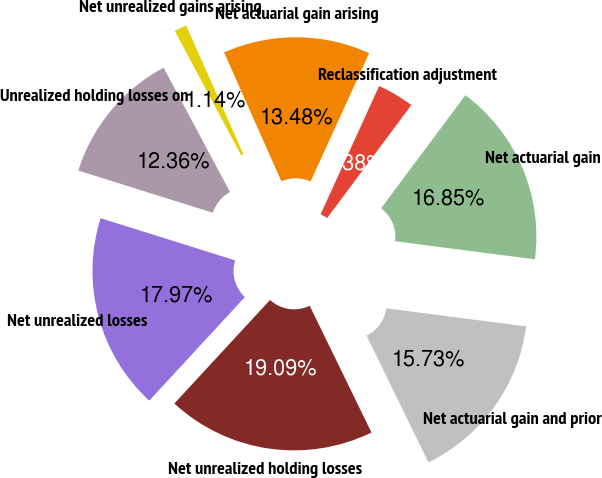Convert chart. <chart><loc_0><loc_0><loc_500><loc_500><pie_chart><fcel>Net actuarial gain arising<fcel>Reclassification adjustment<fcel>Net actuarial gain<fcel>Net actuarial gain and prior<fcel>Net unrealized holding losses<fcel>Net unrealized losses<fcel>Unrealized holding losses on<fcel>Net unrealized gains arising<nl><fcel>13.48%<fcel>3.38%<fcel>16.85%<fcel>15.73%<fcel>19.09%<fcel>17.97%<fcel>12.36%<fcel>1.14%<nl></chart> 